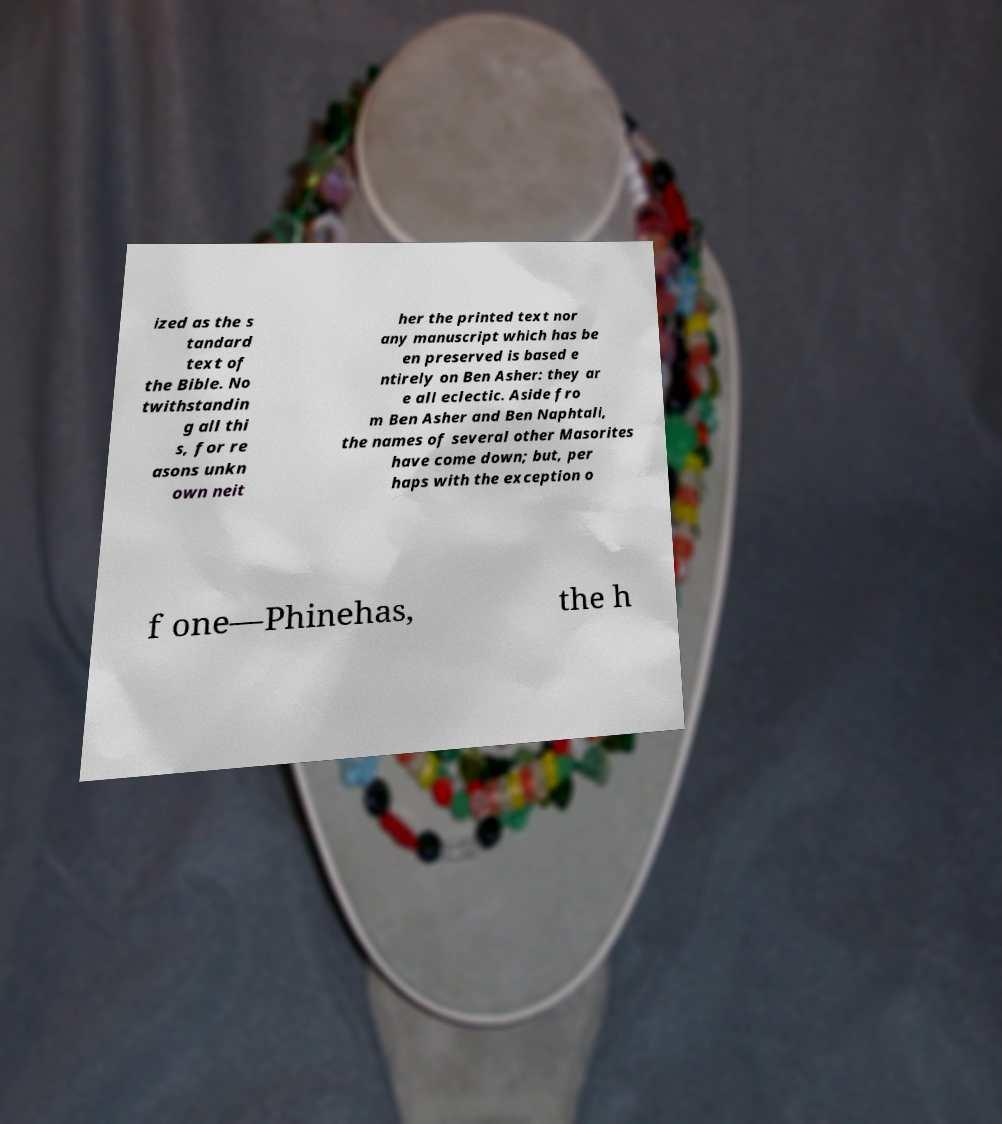I need the written content from this picture converted into text. Can you do that? ized as the s tandard text of the Bible. No twithstandin g all thi s, for re asons unkn own neit her the printed text nor any manuscript which has be en preserved is based e ntirely on Ben Asher: they ar e all eclectic. Aside fro m Ben Asher and Ben Naphtali, the names of several other Masorites have come down; but, per haps with the exception o f one—Phinehas, the h 